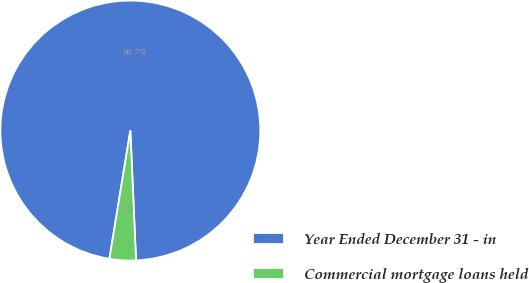Convert chart. <chart><loc_0><loc_0><loc_500><loc_500><pie_chart><fcel>Year Ended December 31 - in<fcel>Commercial mortgage loans held<nl><fcel>96.73%<fcel>3.27%<nl></chart> 